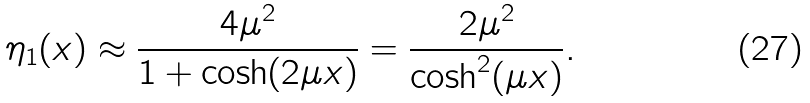<formula> <loc_0><loc_0><loc_500><loc_500>\eta _ { 1 } ( x ) \approx \frac { 4 \mu ^ { 2 } } { 1 + \cosh ( 2 \mu x ) } = \frac { 2 \mu ^ { 2 } } { \cosh ^ { 2 } ( \mu x ) } .</formula> 